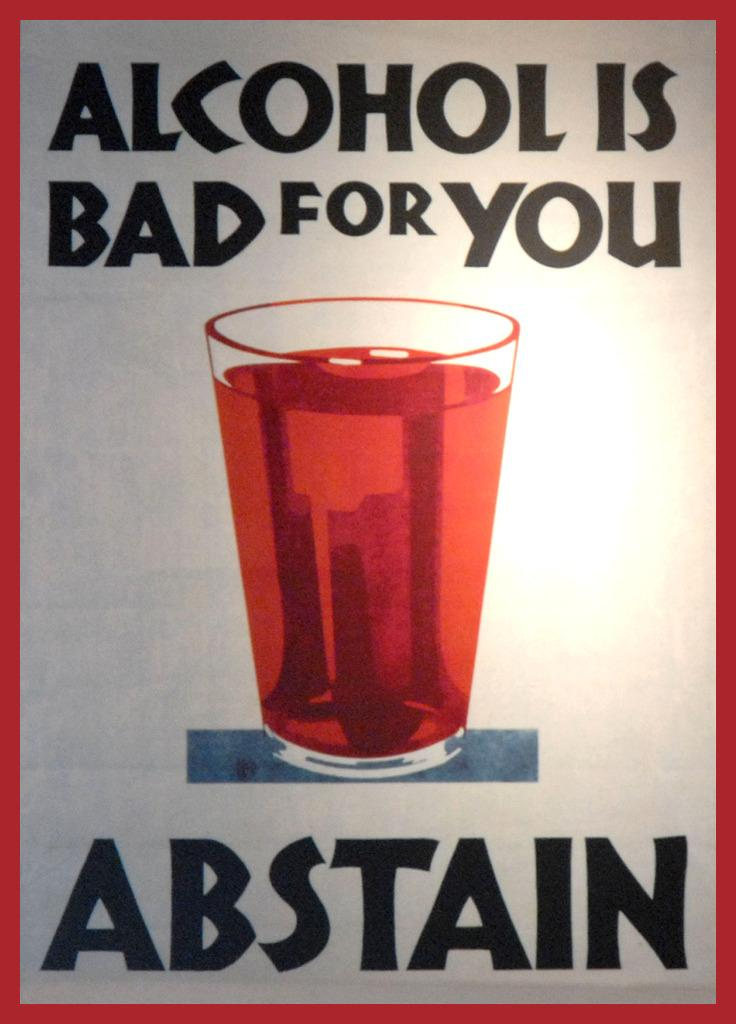What is depicted in the glass in the image? There is a picture of a glass containing a drink in the image. What else can be seen in the image besides the glass? There is text visible in the image. What type of beef can be seen in the image? There is no beef present in the image; it features a picture of a glass containing a drink and text. What kind of teeth are visible in the image? There are no teeth visible in the image. 